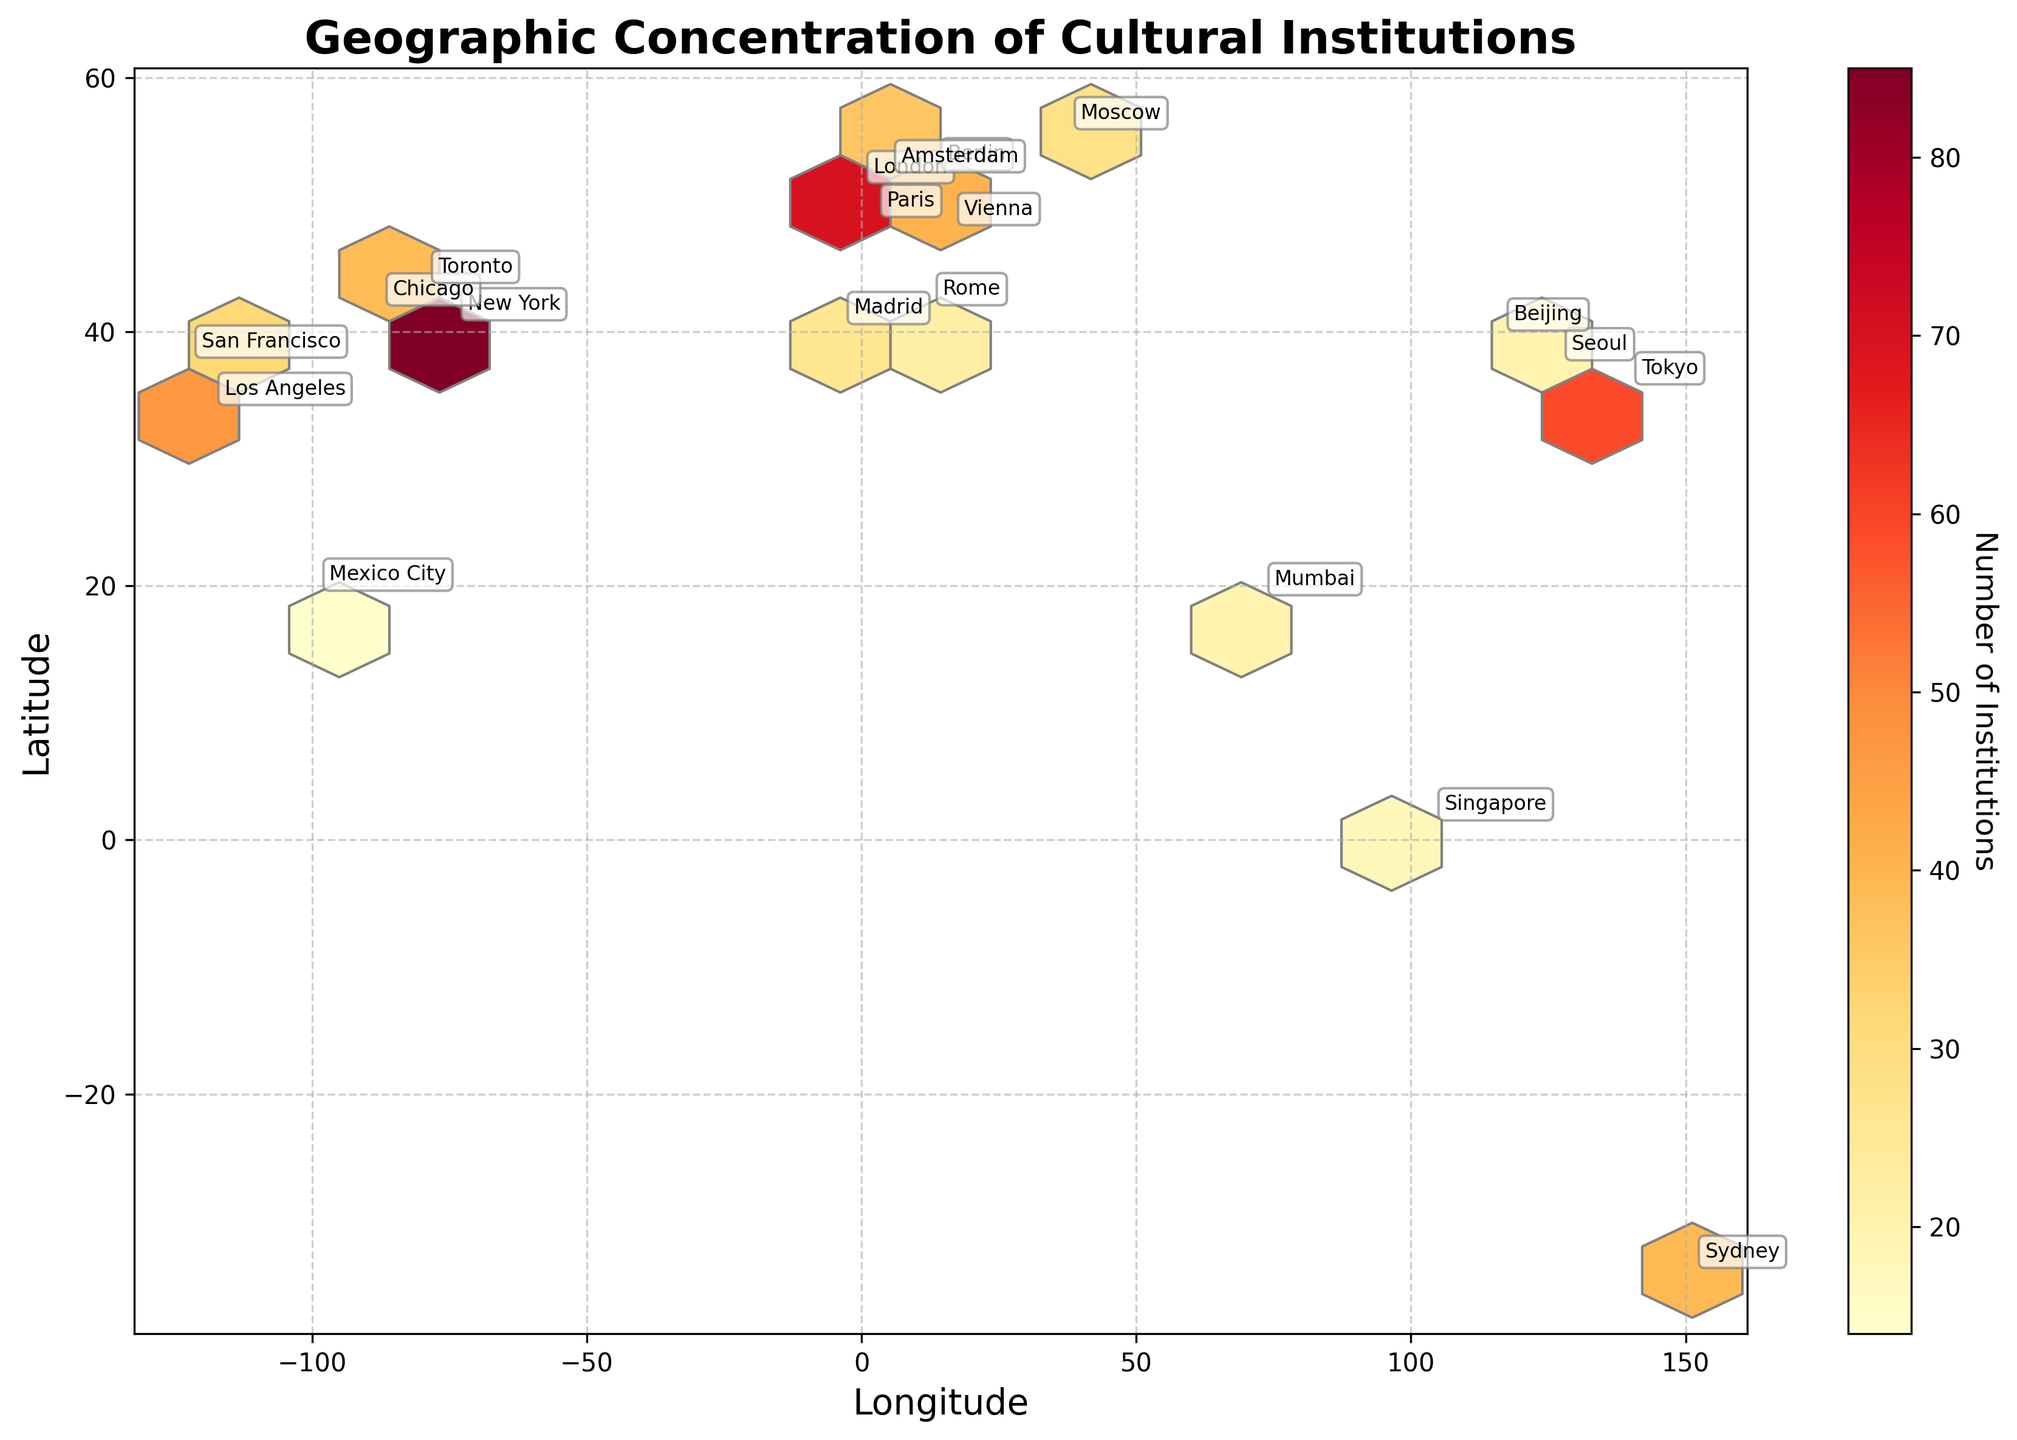how many major cities are labeled in the plot? To find the number of labeled cities, count the number of names displayed on the plot.
Answer: 20 Which city has the highest number of cultural institutions? Look for the city name labeled on the plot and check the color intensity. The color indicates the institution count, and the color bar provides reference.
Answer: New York What does the color bar represent in the plot? The color bar illustrates the number of institutions, with different colors indicating varying institution counts.
Answer: Number of Institutions What's the relationship between geographic location and number of institutions for New York and Los Angeles? Locate New York and Los Angeles on the plot by their labels and check their positions and color intensities which represent institution counts.
Answer: New York has more institutions than Los Angeles Which continents are highly represented based on the concentration of cultural institutions? Identify the cities with high concentrations of cultural institutions based on the color intensity and their geographical locations.
Answer: North America and Europe How does the concentration of cultural institutions in European cities compare to Asian cities? Compare the colors and locations of European cities (like London, Paris, Berlin) with Asian cities (like Tokyo, Seoul, Beijing).
Answer: European cities generally have a higher concentration Which city in Asia has the highest number of cultural institutions, and how is it represented in the plot? Look for Asian cities labeled in the plot and check the color intensity; compare them to determine the highest.
Answer: Tokyo Are there any cities on different continents with a similar number of cultural institutions? Provide an example. Compare the color intensity of cities across different continents. Identify those with similar colors, which indicate similar numbers.
Answer: Toronto and Sydney What specific attribute of the plot helps understand the density of cultural institutions in a hexagonal region? The color intensity within each hexagonal bin indicates the density, and more intense colors show higher institution counts.
Answer: Color Intensity 